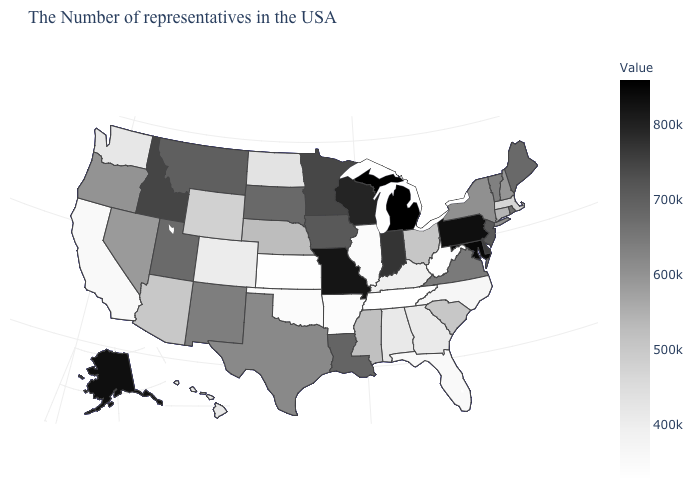Among the states that border Maine , which have the lowest value?
Write a very short answer. New Hampshire. Among the states that border Minnesota , which have the highest value?
Keep it brief. Wisconsin. Which states hav the highest value in the South?
Give a very brief answer. Maryland. 